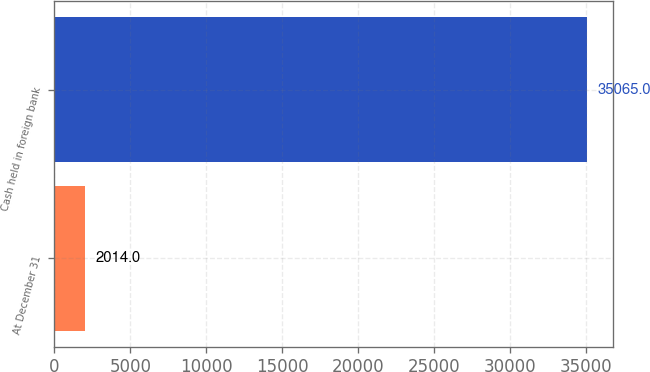Convert chart. <chart><loc_0><loc_0><loc_500><loc_500><bar_chart><fcel>At December 31<fcel>Cash held in foreign bank<nl><fcel>2014<fcel>35065<nl></chart> 